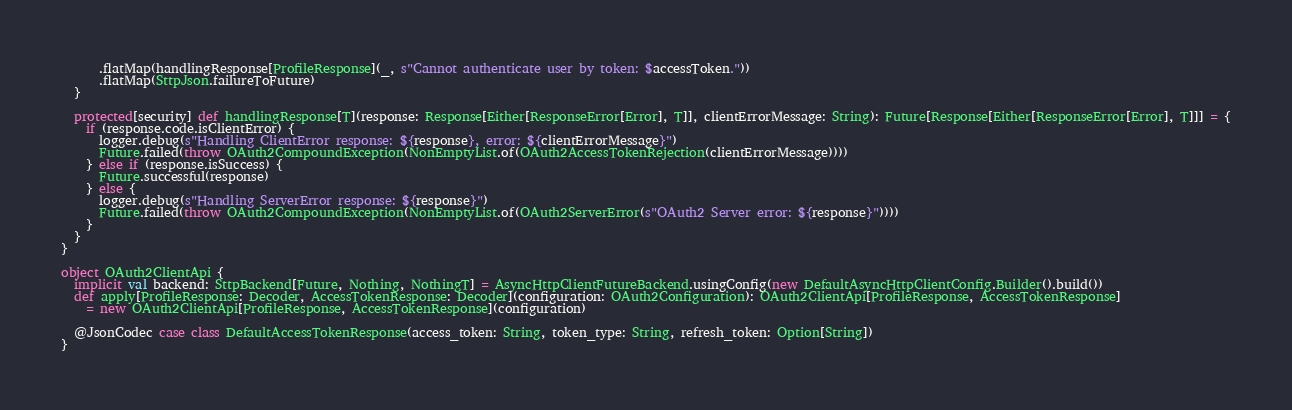Convert code to text. <code><loc_0><loc_0><loc_500><loc_500><_Scala_>      .flatMap(handlingResponse[ProfileResponse](_, s"Cannot authenticate user by token: $accessToken."))
      .flatMap(SttpJson.failureToFuture)
  }

  protected[security] def handlingResponse[T](response: Response[Either[ResponseError[Error], T]], clientErrorMessage: String): Future[Response[Either[ResponseError[Error], T]]] = {
    if (response.code.isClientError) {
      logger.debug(s"Handling ClientError response: ${response}, error: ${clientErrorMessage}")
      Future.failed(throw OAuth2CompoundException(NonEmptyList.of(OAuth2AccessTokenRejection(clientErrorMessage))))
    } else if (response.isSuccess) {
      Future.successful(response)
    } else {
      logger.debug(s"Handling ServerError response: ${response}")
      Future.failed(throw OAuth2CompoundException(NonEmptyList.of(OAuth2ServerError(s"OAuth2 Server error: ${response}"))))
    }
  }
}

object OAuth2ClientApi {
  implicit val backend: SttpBackend[Future, Nothing, NothingT] = AsyncHttpClientFutureBackend.usingConfig(new DefaultAsyncHttpClientConfig.Builder().build())
  def apply[ProfileResponse: Decoder, AccessTokenResponse: Decoder](configuration: OAuth2Configuration): OAuth2ClientApi[ProfileResponse, AccessTokenResponse]
    = new OAuth2ClientApi[ProfileResponse, AccessTokenResponse](configuration)

  @JsonCodec case class DefaultAccessTokenResponse(access_token: String, token_type: String, refresh_token: Option[String])
}
</code> 